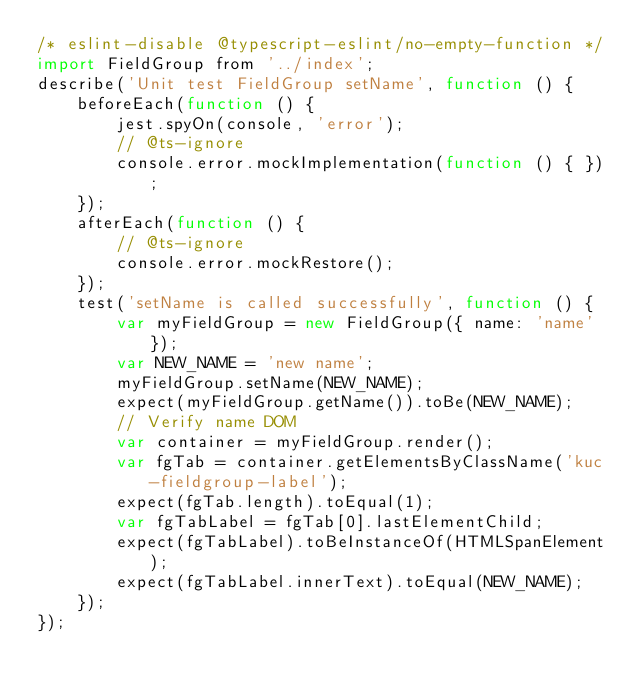<code> <loc_0><loc_0><loc_500><loc_500><_JavaScript_>/* eslint-disable @typescript-eslint/no-empty-function */
import FieldGroup from '../index';
describe('Unit test FieldGroup setName', function () {
    beforeEach(function () {
        jest.spyOn(console, 'error');
        // @ts-ignore
        console.error.mockImplementation(function () { });
    });
    afterEach(function () {
        // @ts-ignore
        console.error.mockRestore();
    });
    test('setName is called successfully', function () {
        var myFieldGroup = new FieldGroup({ name: 'name' });
        var NEW_NAME = 'new name';
        myFieldGroup.setName(NEW_NAME);
        expect(myFieldGroup.getName()).toBe(NEW_NAME);
        // Verify name DOM
        var container = myFieldGroup.render();
        var fgTab = container.getElementsByClassName('kuc-fieldgroup-label');
        expect(fgTab.length).toEqual(1);
        var fgTabLabel = fgTab[0].lastElementChild;
        expect(fgTabLabel).toBeInstanceOf(HTMLSpanElement);
        expect(fgTabLabel.innerText).toEqual(NEW_NAME);
    });
});
</code> 